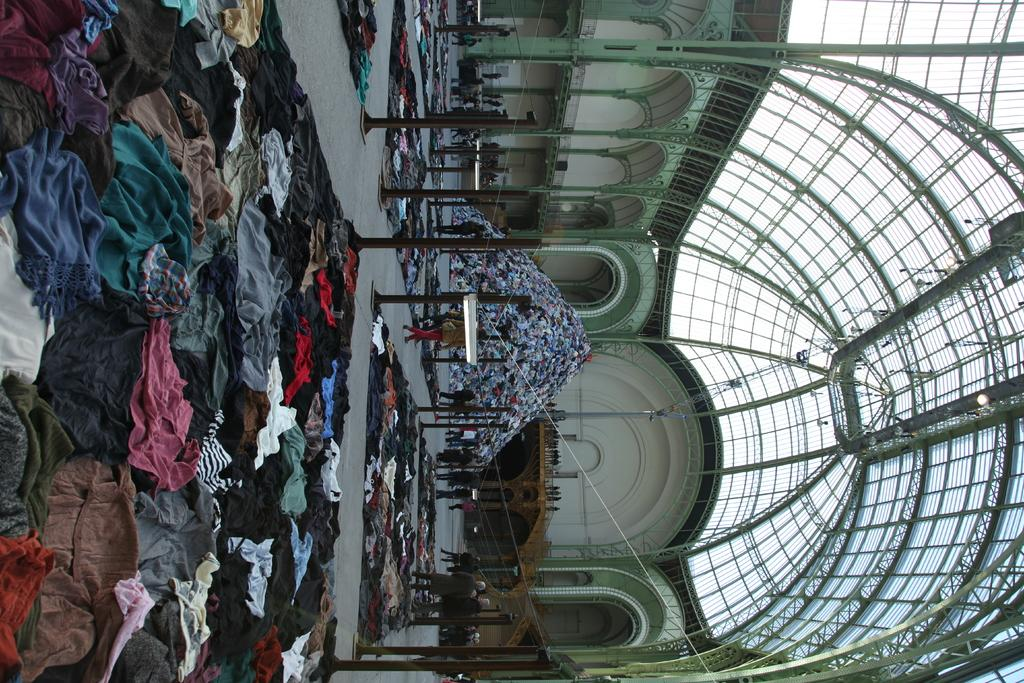What is the main subject of the image? The main subject of the image is a pile of clothes. What else can be seen in the image besides the pile of clothes? There are poles, clothes arranged on the floor, a metal rooftop of a building, and people walking in the image. What type of structure are the poles part of? The information provided does not specify the type of structure the poles are part of. What is the material of the rooftop in the image? The rooftop in the image is made of metal. What type of noise can be heard coming from the clothes in the image? There is no indication of any noise coming from the clothes in the image. Is there any snow visible in the image? There is no mention of snow in the image; it only mentions a pile of clothes, poles, clothes arranged on the floor, a metal rooftop, and people walking. 